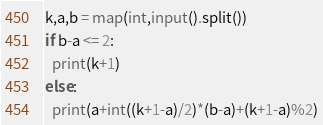Convert code to text. <code><loc_0><loc_0><loc_500><loc_500><_Python_>k,a,b = map(int,input().split())
if b-a <= 2:
  print(k+1)
else:
  print(a+int((k+1-a)/2)*(b-a)+(k+1-a)%2)
</code> 